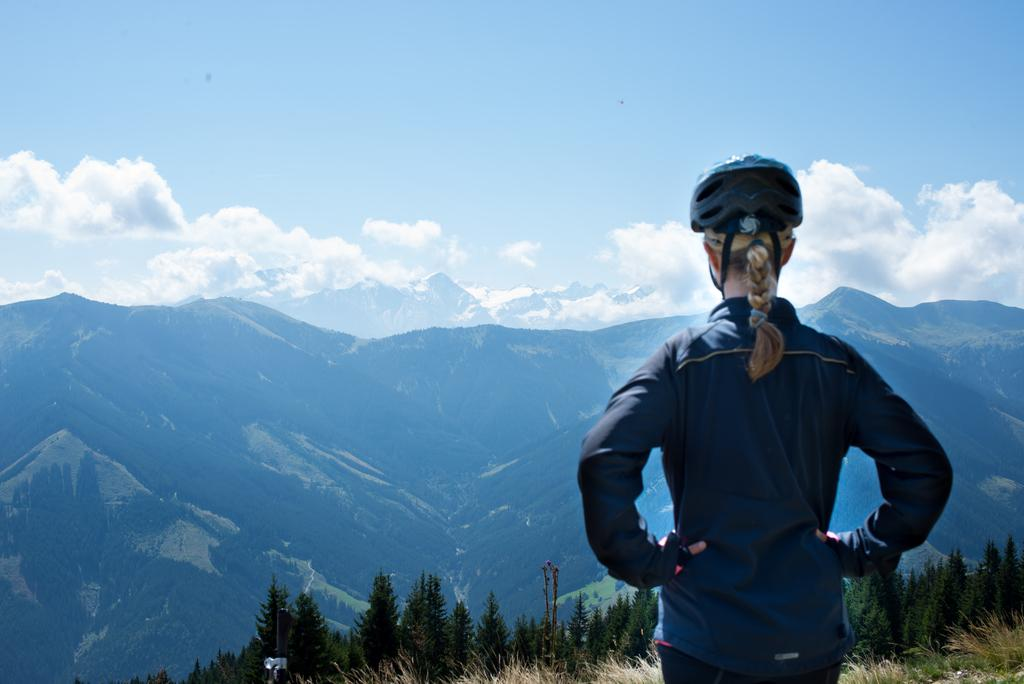What is the main subject of the image? There is a lady standing in the image. What can be seen in the background of the image? There are trees, mountains, and the sky visible in the background of the image. What type of cord is being used by the lady in the image? There is no cord present in the image. Can you see a kitty playing in the trees in the background of the image? There is no kitty present in the image. 